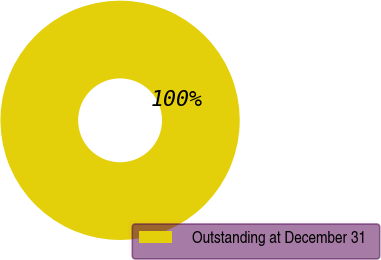Convert chart. <chart><loc_0><loc_0><loc_500><loc_500><pie_chart><fcel>Outstanding at December 31<nl><fcel>100.0%<nl></chart> 